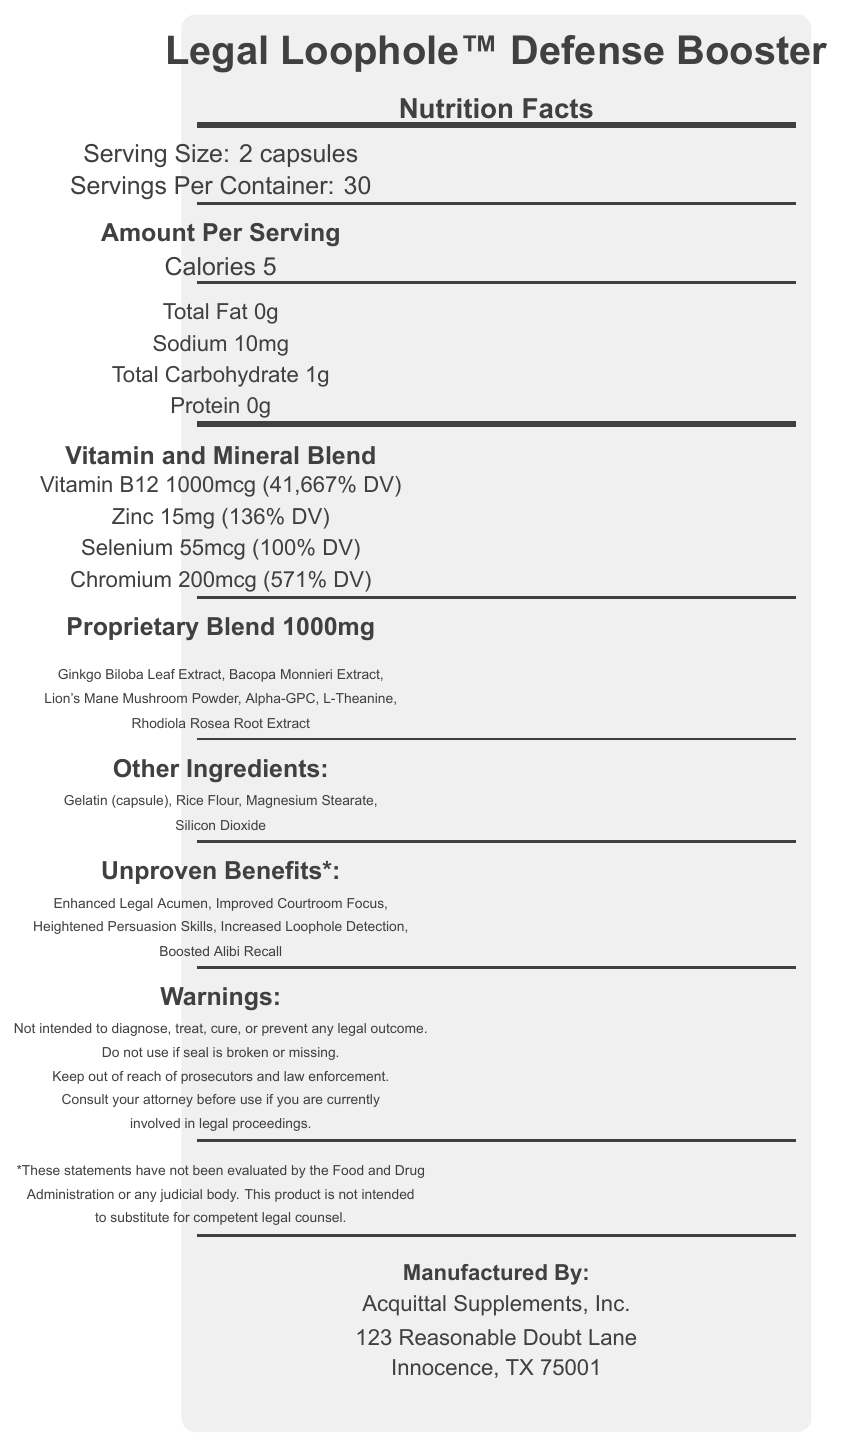what is the serving size for the Legal Loophole™ Defense Booster? The serving size is explicitly stated in the document under "Serving Size: 2 capsules."
Answer: 2 capsules how many calories are in each serving of Legal Loophole™ Defense Booster? According to the "Amount Per Serving" section, each serving contains 5 calories.
Answer: 5 what is the total amount of the proprietary blend per serving? The document notes "Proprietary Blend 1000mg."
Answer: 1000mg what percentage of the daily value of Zinc is provided in each serving? In the "Vitamin and Mineral Blend" section, it states "Zinc (as Zinc Oxide): 15mg (136% DV)."
Answer: 136% DV which ingredient in the proprietary blend comes first in the list? The first ingredient listed under the "Proprietary Blend" section is "Ginkgo Biloba Leaf Extract."
Answer: Ginkgo Biloba Leaf Extract which of the following is NOT an unproven benefit listed on the label? A. Enhanced Legal Acumen B. Heightened Persuasion Skills C. Improved Memory "Enhanced Legal Acumen" and "Heightened Persuasion Skills" are listed; "Improved Memory" is not.
Answer: C where is Acquittal Supplements, Inc. located? A. Innocence, TX B. Guiltless, NV C. Freedom, CA D. Blameless, AZ The address provided for Acquittal Supplements, Inc. is "123 Reasonable Doubt Lane, Innocence, TX 75001."
Answer: A are the benefits of this product FDA approved? The document clearly states that these benefits have not been evaluated by the FDA or any judicial body.
Answer: No is the product intended to be a substitute for legal counsel? The disclaimer specifies that this product is not intended to substitute for competent legal counsel.
Answer: No what warning is given regarding the seal of the product? One of the warnings is "Do not use if seal is broken or missing."
Answer: Do not use if seal is broken or missing how many servings are in one container of Legal Loophole™ Defense Booster? The document states "Servings Per Container: 30."
Answer: 30 describe the main idea of the document The document primarily serves to inform consumers about the nutritional content, ingredients, and purported benefits of the Legal Loophole™ Defense Booster, as well as to provide necessary legal disclaimers and warnings.
Answer: The document is a Nutrition Facts Label for the Legal Loophole™ Defense Booster, a vitamin supplement. It provides detailed information about the serving size, nutrition facts, vitamin and mineral content, a proprietary blend of ingredients, other ingredients, and several unproven benefits related to legal performance. The label also includes warnings and a disclaimer emphasizing that the product's benefits are not evaluated by the FDA and should not replace legal counsel. The product is manufactured by Acquittal Supplements, Inc., located at 123 Reasonable Doubt Lane, Innocence, TX 75001. does the product contain any protein? The "Amount Per Serving" section lists protein as "0g."
Answer: No why should you consult your attorney before using the product if you are currently involved in legal proceedings? One of the listed warnings states, "Consult your attorney before use if you are currently involved in legal proceedings."
Answer: As a precaution advised by the warnings which vitamins and minerals are included in the blend? A. Vitamin A, Iron, Calcium B. Vitamin C, Potassium, Magnesium C. Vitamin B12, Zinc, Selenium, Chromium D. Vitamin D, Manganese, Copper The "Vitamin and Mineral Blend" section lists Vitamin B12, Zinc, Selenium, and Chromium.
Answer: C how much Vitamin B12 is in each serving? The document specifies Vitamin B12 as "1000mcg (41,667% DV)."
Answer: 1000mcg (41,667% DV) can you determine the exact amounts of each ingredient in the proprietary blend? The document lists the total amount but not the specific quantities of each ingredient in the proprietary blend.
Answer: No 